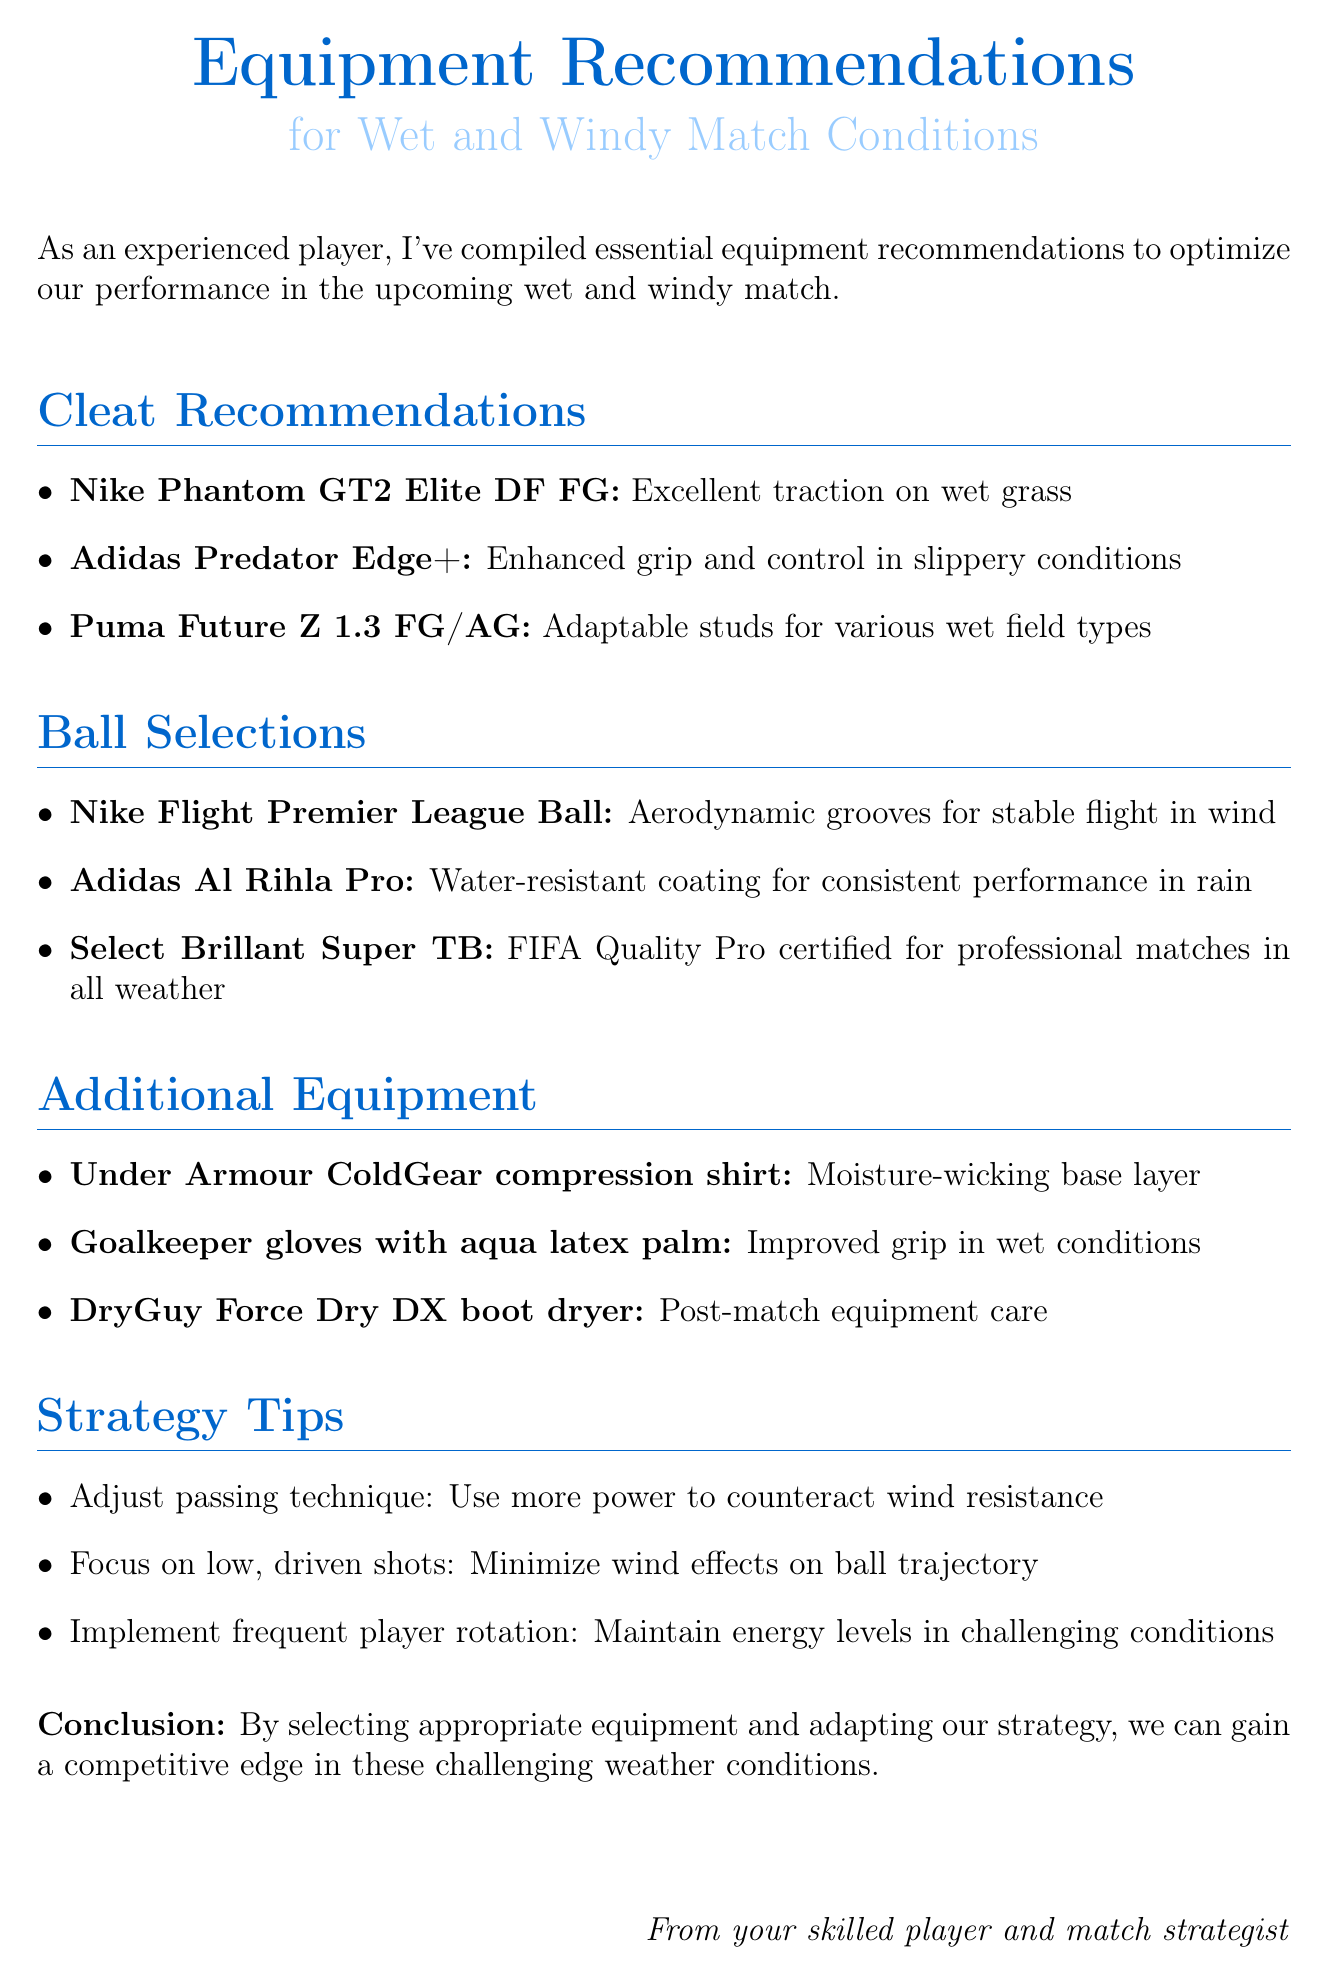What is the subject of the email? The subject of the email indicates the focus of the content, which is on equipment recommendations given specific weather conditions.
Answer: Equipment Recommendations for Wet and Windy Match Conditions How many cleat recommendations are provided? The document lists specific types of cleats, making it easy to count them.
Answer: Three Which ball is noted for its aerodynamic grooves? The specific ball mentioned for its aerodynamic features is highlighted in the ball selections section.
Answer: Nike Flight Premier League Ball What type of gloves is recommended for wet conditions? The document specifies a type of gloves designed to improve grip in wet weather, providing clear details.
Answer: Goalkeeper gloves with aqua latex palm What is one of the strategy tips mentioned? The document contains tips aimed at improving performance under challenging weather, showcasing strategic adaptations.
Answer: Adjust passing technique How many types of additional equipment are suggested? Counting the items listed under the additional equipment section gives a straightforward answer.
Answer: Three What is the main benefit of the Adidas Al Rihla Pro ball? The document highlights features that enhance performance in adverse weather conditions, particularly focusing on water resistance.
Answer: Water-resistant coating What is the purpose of the DryGuy Force Dry DX? The specific item mentioned provides insights into post-match care, explaining its relevance in equipment maintenance.
Answer: Post-match equipment care What should players focus on to minimize wind effects? The document provides practical tips for adapting to windy conditions, emphasizing changes to shooting techniques.
Answer: Low, driven shots 